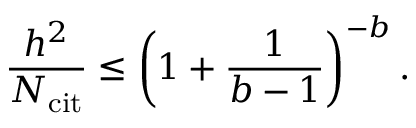Convert formula to latex. <formula><loc_0><loc_0><loc_500><loc_500>\frac { h ^ { 2 } } { N _ { c i t } } \leq \left ( 1 + \frac { 1 } { b - 1 } \right ) ^ { - b } .</formula> 